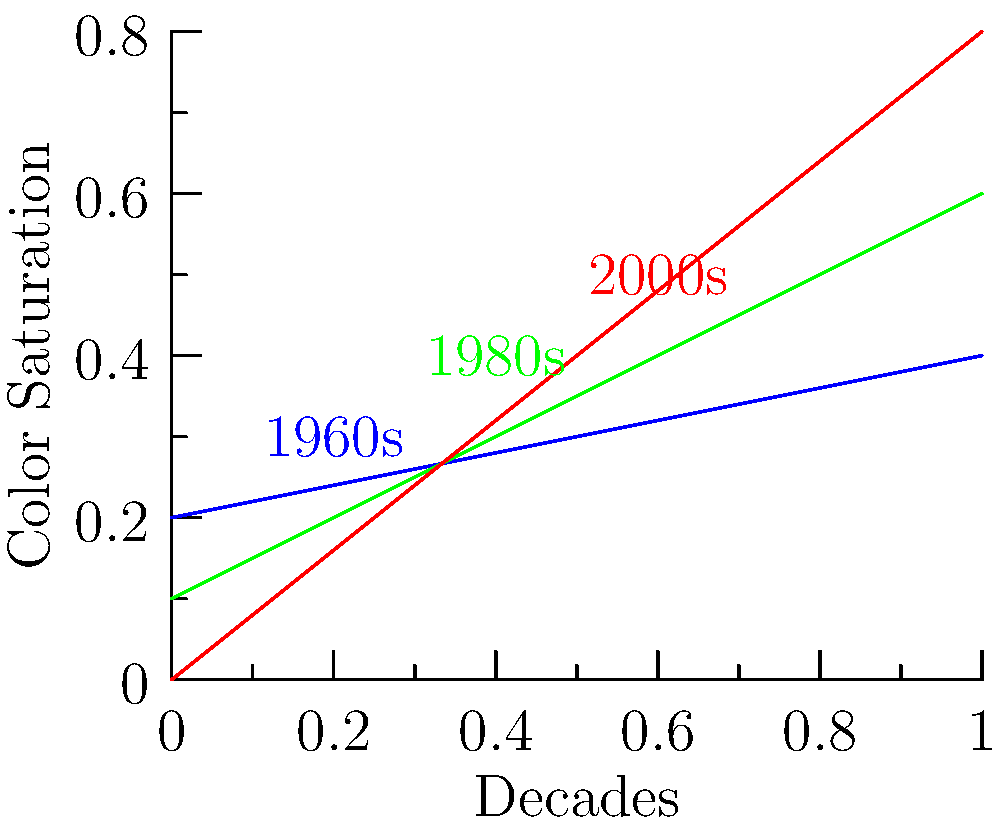Based on the graph showing the evolution of color saturation in sci-fi films across decades, which trend is most evident in the progression from the 1960s to the 2000s? To analyze the trend in color saturation across decades in sci-fi films, let's examine the graph step-by-step:

1. The blue line represents the 1960s, showing a relatively low and gradual increase in color saturation.
2. The green line represents the 1980s, displaying a steeper slope and higher overall saturation compared to the 1960s.
3. The red line represents the 2000s, exhibiting the steepest slope and highest saturation levels.

4. Comparing the slopes:
   - 1960s (blue): Approximately 0.2
   - 1980s (green): Approximately 0.5
   - 2000s (red): Approximately 0.8

5. Analyzing the y-intercepts:
   - 1960s: Starts at about 0.2
   - 1980s: Starts at about 0.1
   - 2000s: Starts at 0

6. Observing the overall pattern:
   - Each subsequent decade shows a higher slope and generally higher saturation levels.
   - The increase in slope indicates a more rapid change in saturation within each decade.

7. Conclusion:
   The most evident trend is an increasing use of saturated colors and a more dynamic range of color saturation within each film as we progress from the 1960s to the 2000s.
Answer: Increasing color saturation and dynamic range 